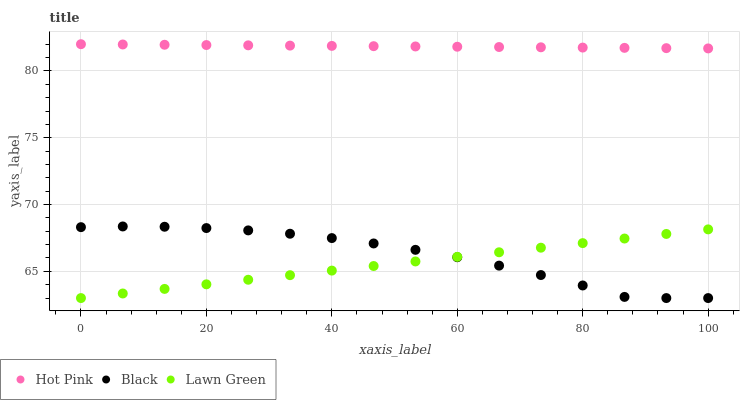Does Lawn Green have the minimum area under the curve?
Answer yes or no. Yes. Does Hot Pink have the maximum area under the curve?
Answer yes or no. Yes. Does Black have the minimum area under the curve?
Answer yes or no. No. Does Black have the maximum area under the curve?
Answer yes or no. No. Is Lawn Green the smoothest?
Answer yes or no. Yes. Is Black the roughest?
Answer yes or no. Yes. Is Hot Pink the smoothest?
Answer yes or no. No. Is Hot Pink the roughest?
Answer yes or no. No. Does Lawn Green have the lowest value?
Answer yes or no. Yes. Does Hot Pink have the lowest value?
Answer yes or no. No. Does Hot Pink have the highest value?
Answer yes or no. Yes. Does Black have the highest value?
Answer yes or no. No. Is Black less than Hot Pink?
Answer yes or no. Yes. Is Hot Pink greater than Black?
Answer yes or no. Yes. Does Lawn Green intersect Black?
Answer yes or no. Yes. Is Lawn Green less than Black?
Answer yes or no. No. Is Lawn Green greater than Black?
Answer yes or no. No. Does Black intersect Hot Pink?
Answer yes or no. No. 